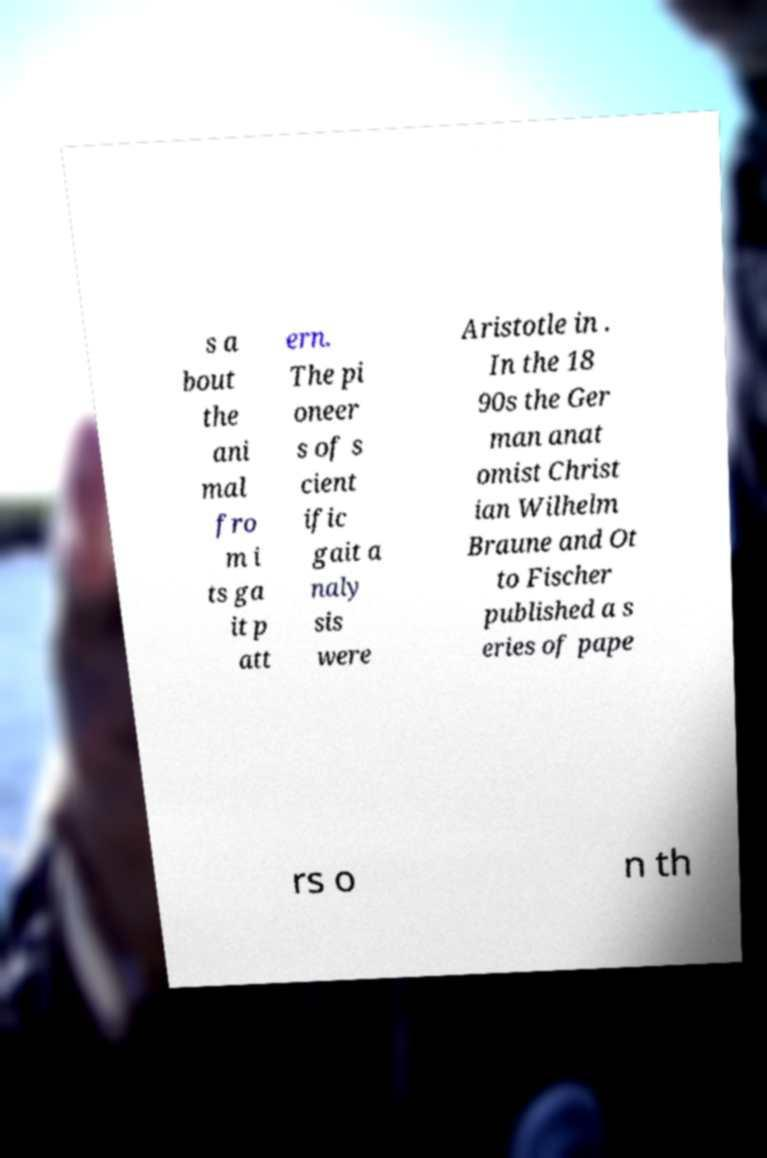Can you read and provide the text displayed in the image?This photo seems to have some interesting text. Can you extract and type it out for me? s a bout the ani mal fro m i ts ga it p att ern. The pi oneer s of s cient ific gait a naly sis were Aristotle in . In the 18 90s the Ger man anat omist Christ ian Wilhelm Braune and Ot to Fischer published a s eries of pape rs o n th 